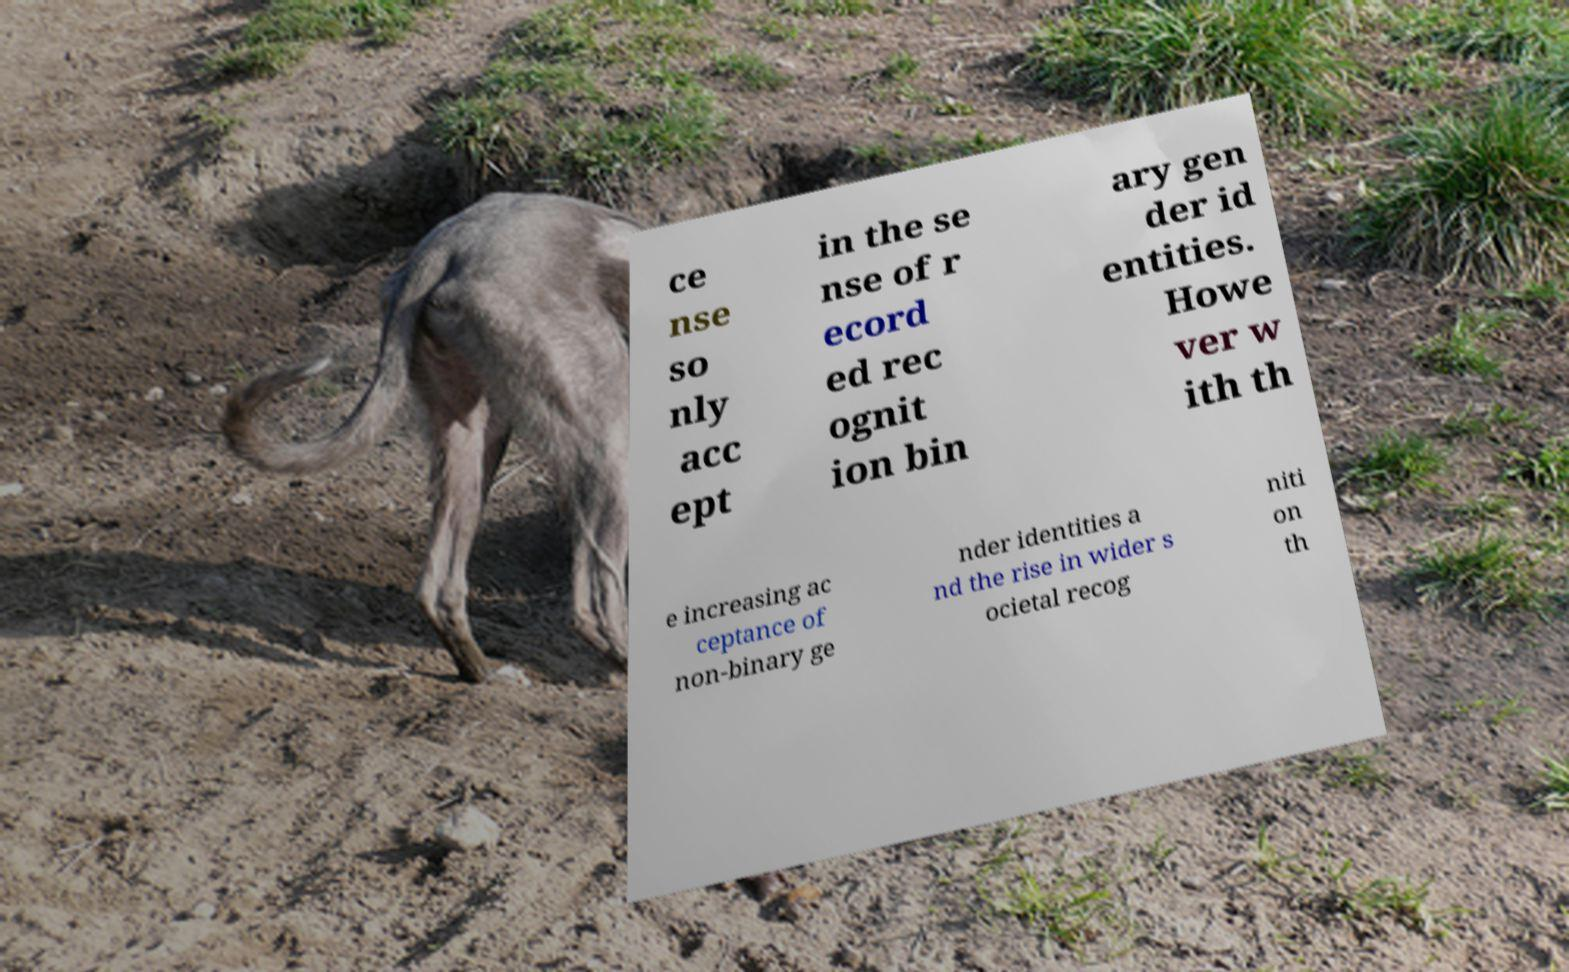For documentation purposes, I need the text within this image transcribed. Could you provide that? ce nse so nly acc ept in the se nse of r ecord ed rec ognit ion bin ary gen der id entities. Howe ver w ith th e increasing ac ceptance of non-binary ge nder identities a nd the rise in wider s ocietal recog niti on th 